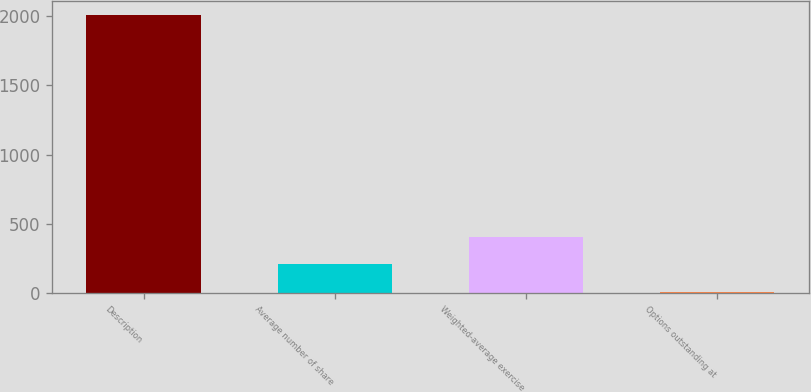Convert chart. <chart><loc_0><loc_0><loc_500><loc_500><bar_chart><fcel>Description<fcel>Average number of share<fcel>Weighted-average exercise<fcel>Options outstanding at<nl><fcel>2006<fcel>207.98<fcel>407.76<fcel>8.2<nl></chart> 